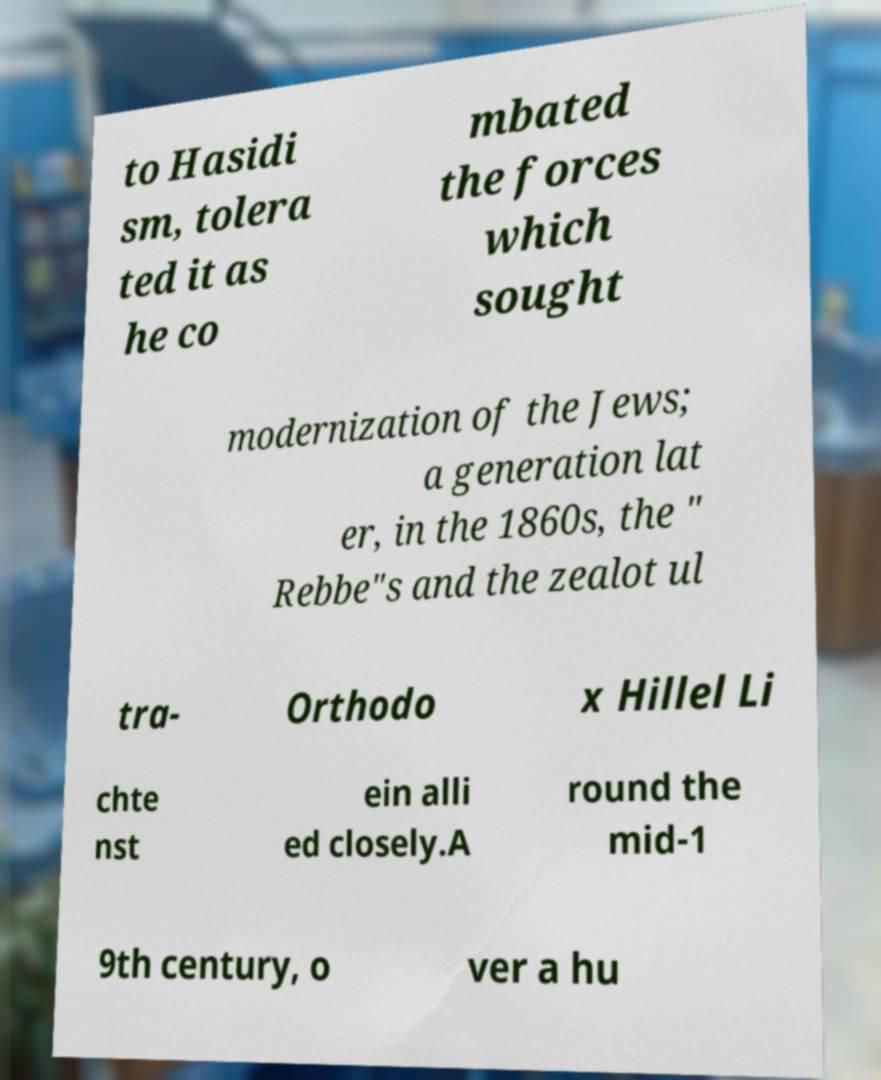Can you accurately transcribe the text from the provided image for me? to Hasidi sm, tolera ted it as he co mbated the forces which sought modernization of the Jews; a generation lat er, in the 1860s, the " Rebbe"s and the zealot ul tra- Orthodo x Hillel Li chte nst ein alli ed closely.A round the mid-1 9th century, o ver a hu 